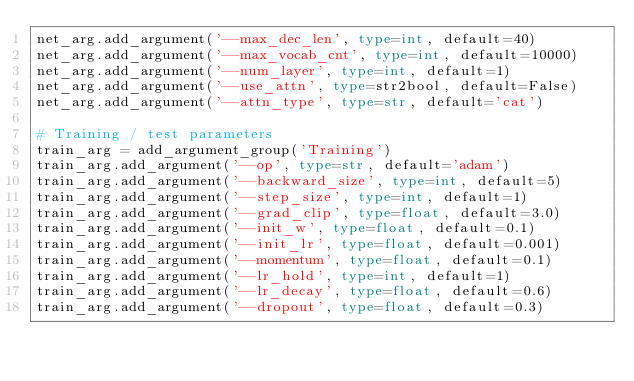Convert code to text. <code><loc_0><loc_0><loc_500><loc_500><_Python_>net_arg.add_argument('--max_dec_len', type=int, default=40)
net_arg.add_argument('--max_vocab_cnt', type=int, default=10000)
net_arg.add_argument('--num_layer', type=int, default=1)
net_arg.add_argument('--use_attn', type=str2bool, default=False)
net_arg.add_argument('--attn_type', type=str, default='cat')

# Training / test parameters
train_arg = add_argument_group('Training')
train_arg.add_argument('--op', type=str, default='adam')
train_arg.add_argument('--backward_size', type=int, default=5)
train_arg.add_argument('--step_size', type=int, default=1)
train_arg.add_argument('--grad_clip', type=float, default=3.0)
train_arg.add_argument('--init_w', type=float, default=0.1)
train_arg.add_argument('--init_lr', type=float, default=0.001)
train_arg.add_argument('--momentum', type=float, default=0.1)
train_arg.add_argument('--lr_hold', type=int, default=1)
train_arg.add_argument('--lr_decay', type=float, default=0.6)
train_arg.add_argument('--dropout', type=float, default=0.3)</code> 